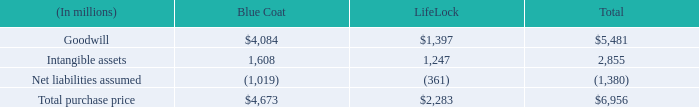Fiscal 2017 acquisitions
On August 1, 2016, we acquired all of the outstanding common stock of Blue Coat, Inc. (Blue Coat), a provider of advanced web security solutions for global enterprises and governments. The addition of Blue Coat’s suite of network and cloud security products to our innovative Enterprise Security product portfolio has enhanced our threat protection and information protection products while providing us with complementary products, such as advanced web and cloud security solutions, that address the network and cloud security needs of enterprises.
On February 9, 2017, we completed the acquisition of LifeLock, Inc. (LifeLock) a provider of proactive identity theft protection services for consumers and consumer risk management services for enterprises. LifeLock’s services are provided on a monthly or annual subscription basis and provide identification and notification of identity-related and other events and assist users in remediating their impact.
The total consideration for the acquisitions, net of cash acquired, consisted of the following:
What was the company acquired in August 1, 2016? Blue coat, inc. (blue coat). What was the company acquired in February 9, 2017? Lifelock, inc. (lifelock). What is the total purchase price for Blue coat?
Answer scale should be: million. $4,673. What is the difference in Total purchase price between Blue Coat and LifeLock?
Answer scale should be: million. 4,673-2,283
Answer: 2390. What is the Goodwill for Blue Coat expressed as a percentage of Total purchase price?
Answer scale should be: percent. 4,084/4,673
Answer: 87.4. What is the Goodwill for LifeLock expressed as a percentage of Total purchase price?
Answer scale should be: percent. 1,397/2,283
Answer: 61.19. 